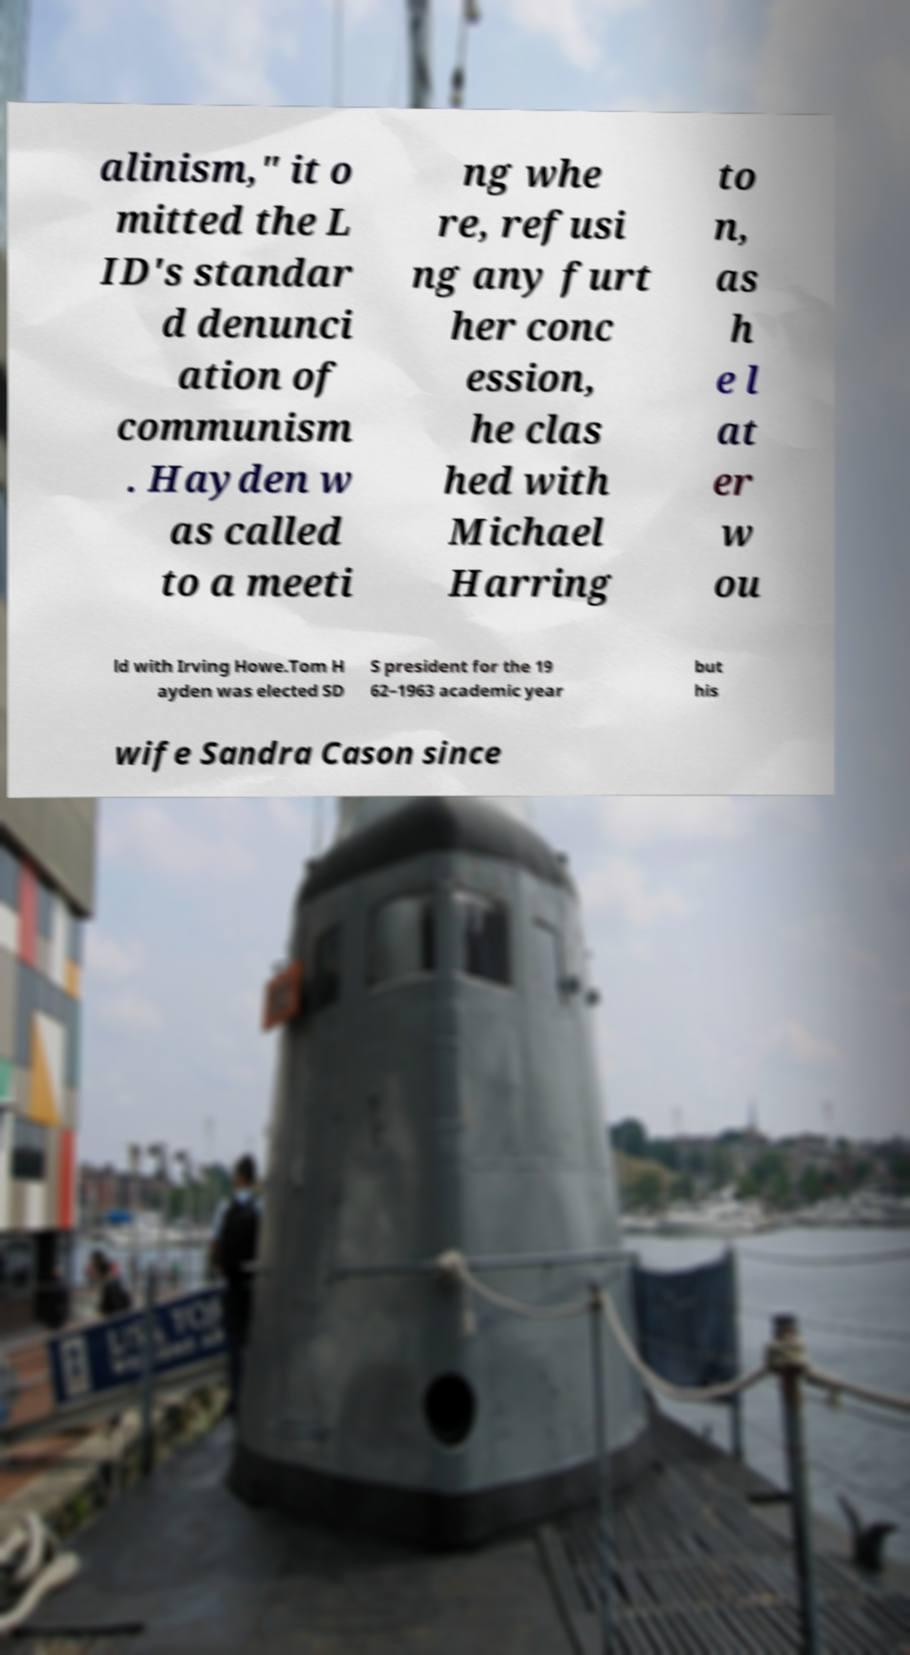I need the written content from this picture converted into text. Can you do that? alinism," it o mitted the L ID's standar d denunci ation of communism . Hayden w as called to a meeti ng whe re, refusi ng any furt her conc ession, he clas hed with Michael Harring to n, as h e l at er w ou ld with Irving Howe.Tom H ayden was elected SD S president for the 19 62–1963 academic year but his wife Sandra Cason since 